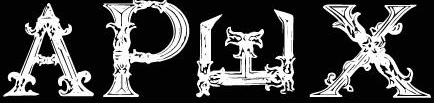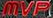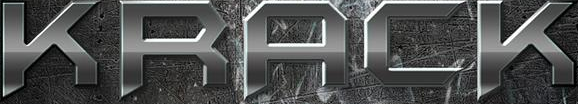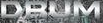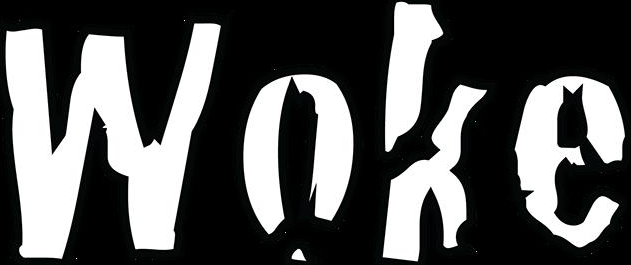What words can you see in these images in sequence, separated by a semicolon? APWX; MVP; KRACK; DRUM; Woke 